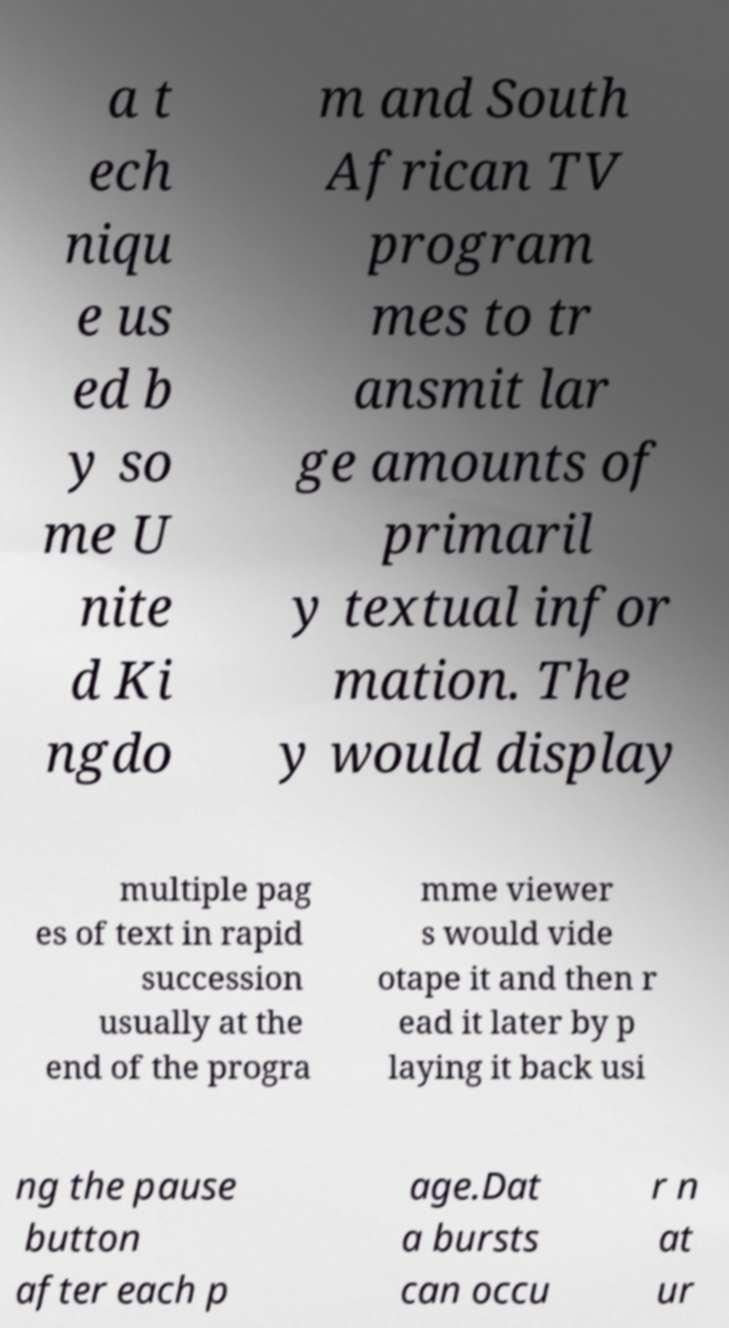Could you extract and type out the text from this image? a t ech niqu e us ed b y so me U nite d Ki ngdo m and South African TV program mes to tr ansmit lar ge amounts of primaril y textual infor mation. The y would display multiple pag es of text in rapid succession usually at the end of the progra mme viewer s would vide otape it and then r ead it later by p laying it back usi ng the pause button after each p age.Dat a bursts can occu r n at ur 